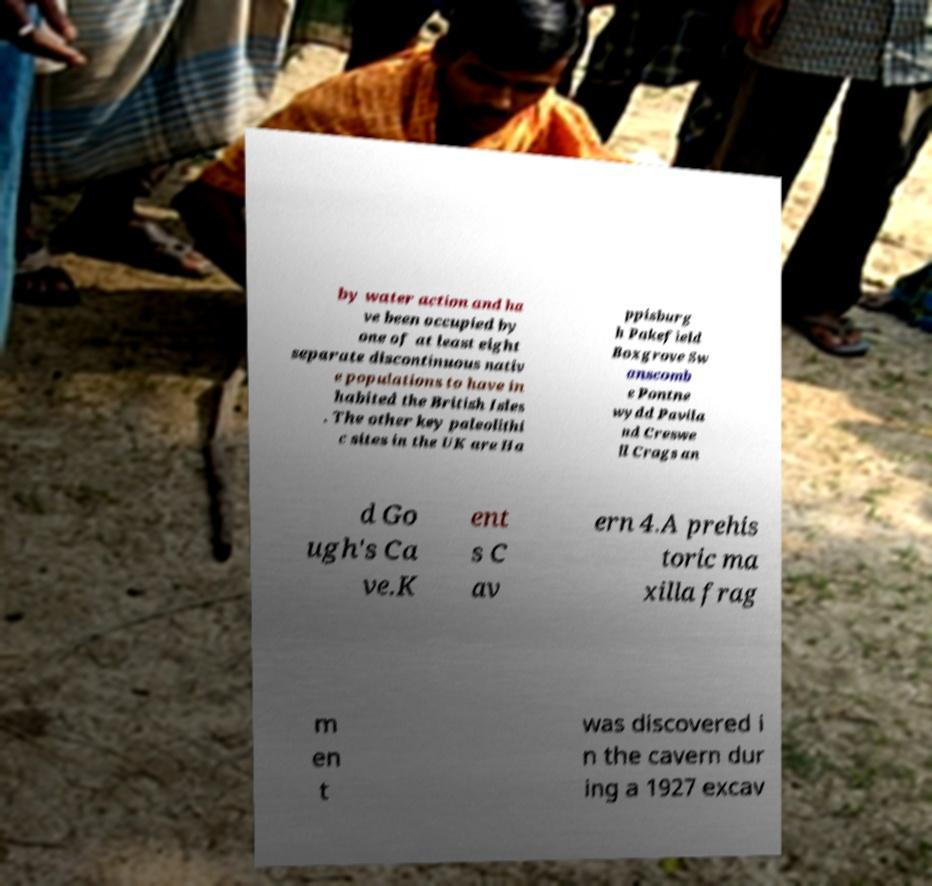There's text embedded in this image that I need extracted. Can you transcribe it verbatim? by water action and ha ve been occupied by one of at least eight separate discontinuous nativ e populations to have in habited the British Isles . The other key paleolithi c sites in the UK are Ha ppisburg h Pakefield Boxgrove Sw anscomb e Pontne wydd Pavila nd Creswe ll Crags an d Go ugh's Ca ve.K ent s C av ern 4.A prehis toric ma xilla frag m en t was discovered i n the cavern dur ing a 1927 excav 